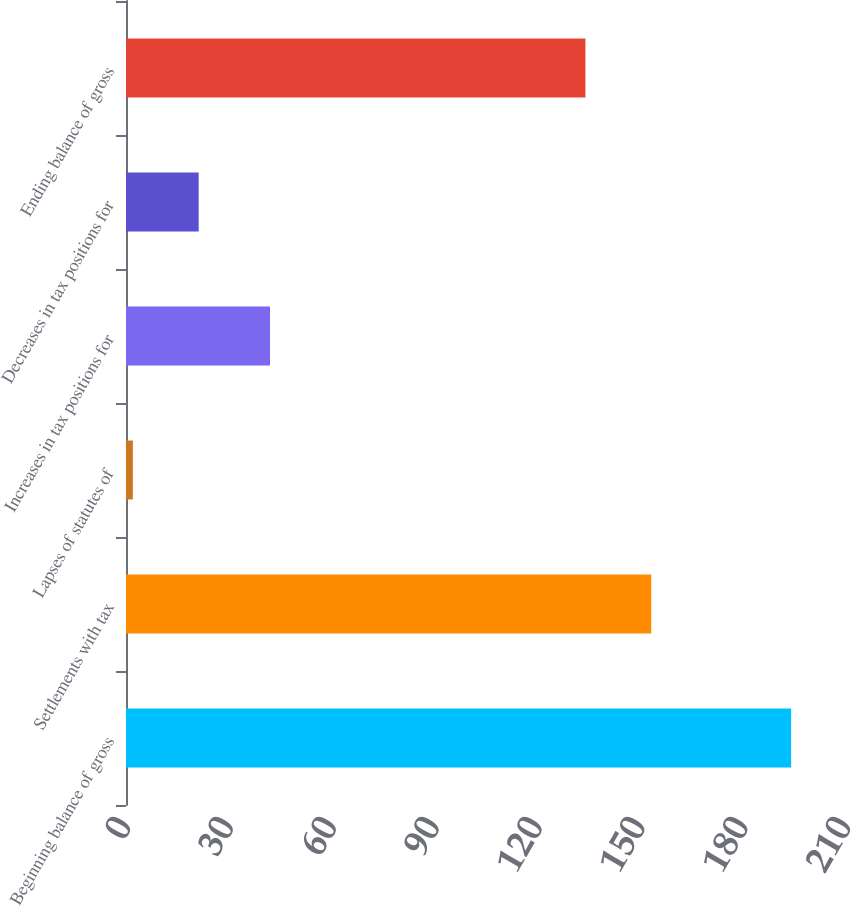<chart> <loc_0><loc_0><loc_500><loc_500><bar_chart><fcel>Beginning balance of gross<fcel>Settlements with tax<fcel>Lapses of statutes of<fcel>Increases in tax positions for<fcel>Decreases in tax positions for<fcel>Ending balance of gross<nl><fcel>194<fcel>153.2<fcel>2<fcel>42<fcel>21.2<fcel>134<nl></chart> 